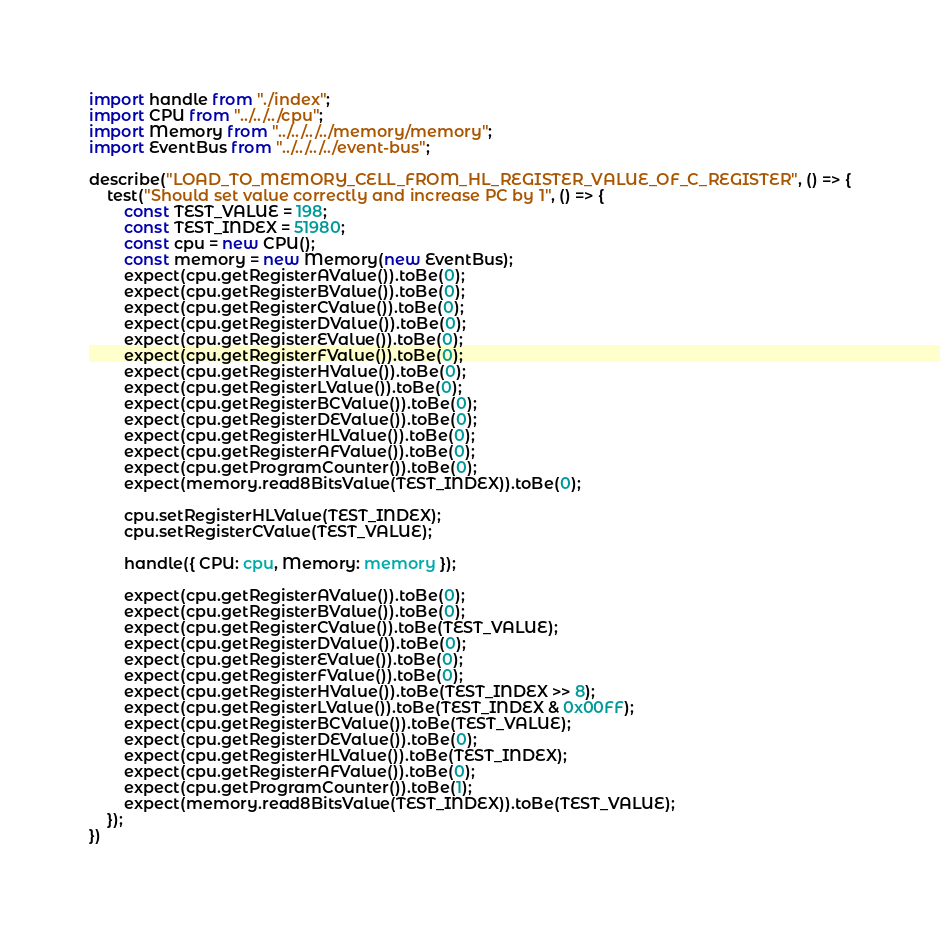Convert code to text. <code><loc_0><loc_0><loc_500><loc_500><_TypeScript_>import handle from "./index";
import CPU from "../../../cpu";
import Memory from "../../../../memory/memory";
import EventBus from "../../../../event-bus";

describe("LOAD_TO_MEMORY_CELL_FROM_HL_REGISTER_VALUE_OF_C_REGISTER", () => {
    test("Should set value correctly and increase PC by 1", () => {
        const TEST_VALUE = 198;
        const TEST_INDEX = 51980;
        const cpu = new CPU();
        const memory = new Memory(new EventBus);
        expect(cpu.getRegisterAValue()).toBe(0);
        expect(cpu.getRegisterBValue()).toBe(0);
        expect(cpu.getRegisterCValue()).toBe(0);
        expect(cpu.getRegisterDValue()).toBe(0);
        expect(cpu.getRegisterEValue()).toBe(0);
        expect(cpu.getRegisterFValue()).toBe(0);
        expect(cpu.getRegisterHValue()).toBe(0);
        expect(cpu.getRegisterLValue()).toBe(0);
        expect(cpu.getRegisterBCValue()).toBe(0);
        expect(cpu.getRegisterDEValue()).toBe(0);
        expect(cpu.getRegisterHLValue()).toBe(0);
        expect(cpu.getRegisterAFValue()).toBe(0);
        expect(cpu.getProgramCounter()).toBe(0);
        expect(memory.read8BitsValue(TEST_INDEX)).toBe(0);

        cpu.setRegisterHLValue(TEST_INDEX);
        cpu.setRegisterCValue(TEST_VALUE);

        handle({ CPU: cpu, Memory: memory });

        expect(cpu.getRegisterAValue()).toBe(0);
        expect(cpu.getRegisterBValue()).toBe(0);
        expect(cpu.getRegisterCValue()).toBe(TEST_VALUE);
        expect(cpu.getRegisterDValue()).toBe(0);
        expect(cpu.getRegisterEValue()).toBe(0);
        expect(cpu.getRegisterFValue()).toBe(0);
        expect(cpu.getRegisterHValue()).toBe(TEST_INDEX >> 8);
        expect(cpu.getRegisterLValue()).toBe(TEST_INDEX & 0x00FF);
        expect(cpu.getRegisterBCValue()).toBe(TEST_VALUE);
        expect(cpu.getRegisterDEValue()).toBe(0);
        expect(cpu.getRegisterHLValue()).toBe(TEST_INDEX);
        expect(cpu.getRegisterAFValue()).toBe(0);
        expect(cpu.getProgramCounter()).toBe(1);
        expect(memory.read8BitsValue(TEST_INDEX)).toBe(TEST_VALUE);
    });
})</code> 